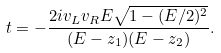Convert formula to latex. <formula><loc_0><loc_0><loc_500><loc_500>t = - \frac { 2 i v _ { L } v _ { R } E \sqrt { 1 - ( E / 2 ) ^ { 2 } } } { ( E - z _ { 1 } ) ( E - z _ { 2 } ) } .</formula> 